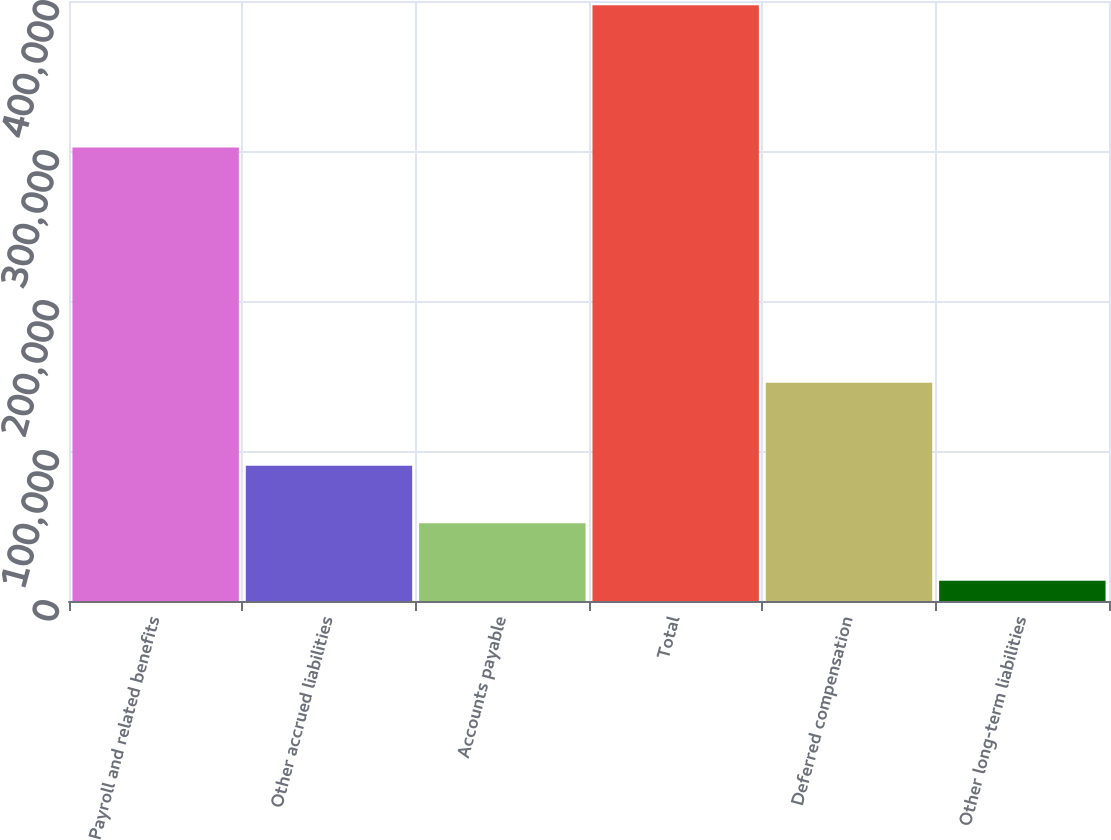<chart> <loc_0><loc_0><loc_500><loc_500><bar_chart><fcel>Payroll and related benefits<fcel>Other accrued liabilities<fcel>Accounts payable<fcel>Total<fcel>Deferred compensation<fcel>Other long-term liabilities<nl><fcel>302295<fcel>90193.8<fcel>51828.9<fcel>397113<fcel>145508<fcel>13464<nl></chart> 